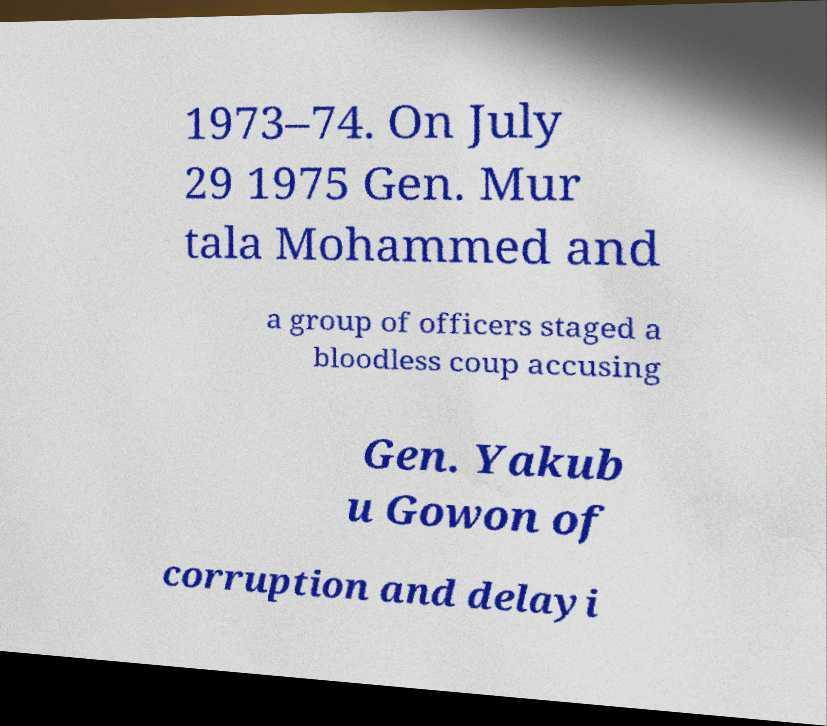I need the written content from this picture converted into text. Can you do that? 1973–74. On July 29 1975 Gen. Mur tala Mohammed and a group of officers staged a bloodless coup accusing Gen. Yakub u Gowon of corruption and delayi 